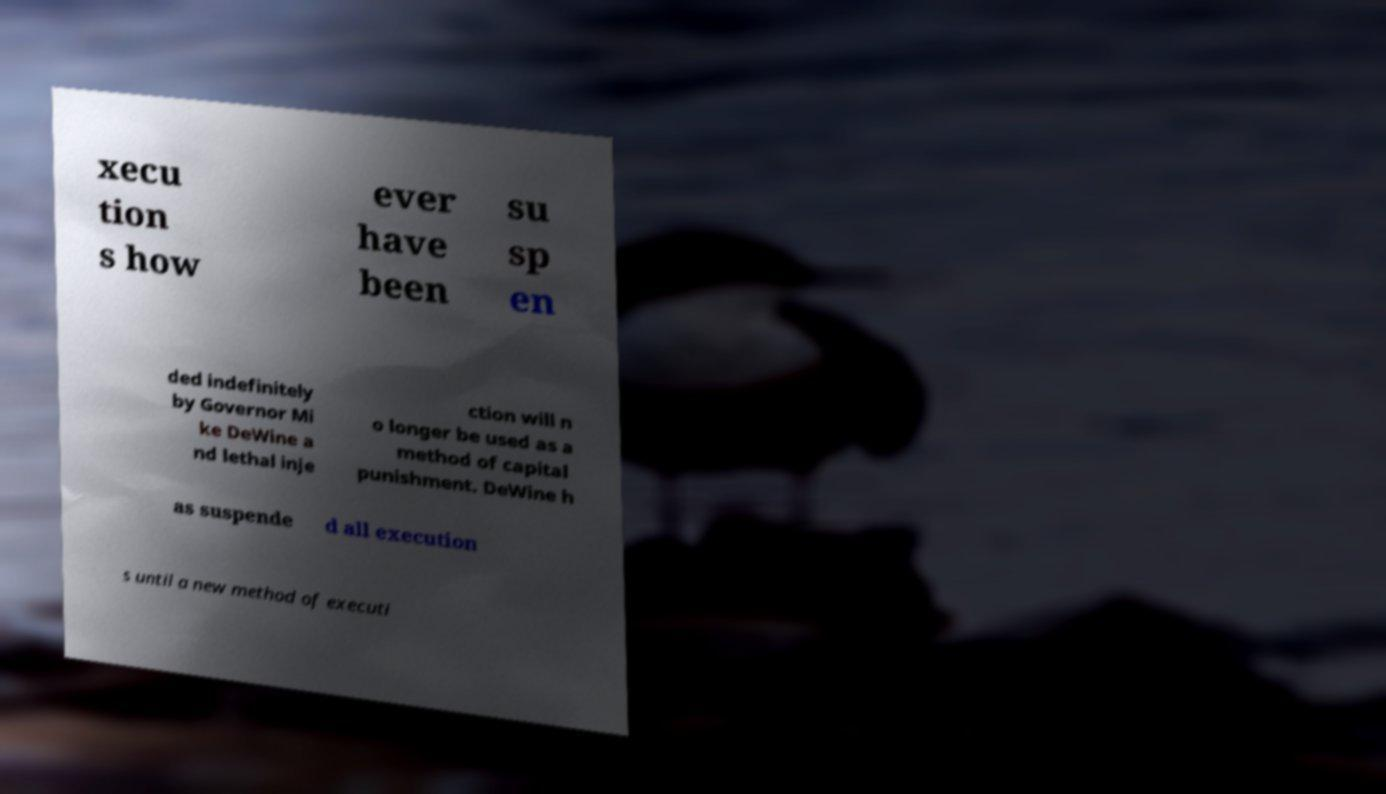Can you accurately transcribe the text from the provided image for me? xecu tion s how ever have been su sp en ded indefinitely by Governor Mi ke DeWine a nd lethal inje ction will n o longer be used as a method of capital punishment. DeWine h as suspende d all execution s until a new method of executi 